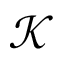Convert formula to latex. <formula><loc_0><loc_0><loc_500><loc_500>\mathcal { K }</formula> 